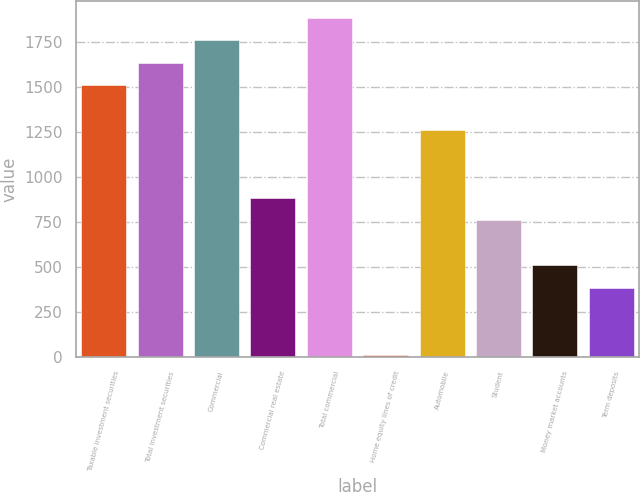<chart> <loc_0><loc_0><loc_500><loc_500><bar_chart><fcel>Taxable investment securities<fcel>Total investment securities<fcel>Commercial<fcel>Commercial real estate<fcel>Total commercial<fcel>Home equity lines of credit<fcel>Automobile<fcel>Student<fcel>Money market accounts<fcel>Term deposits<nl><fcel>1508.6<fcel>1633.4<fcel>1758.2<fcel>884.6<fcel>1883<fcel>11<fcel>1259<fcel>759.8<fcel>510.2<fcel>385.4<nl></chart> 